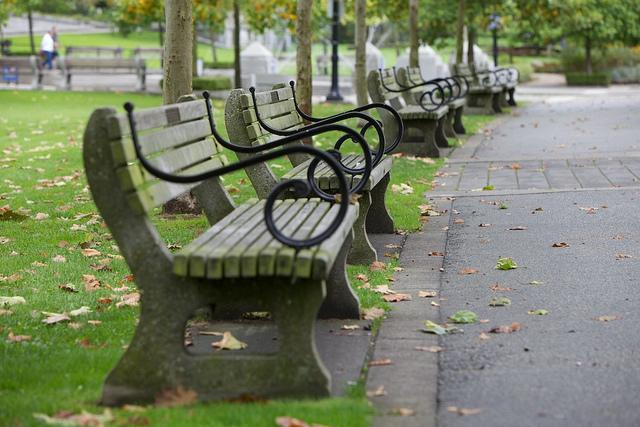What is on the grass?

Choices:
A) antelope
B) cow
C) baby
D) bench bench 